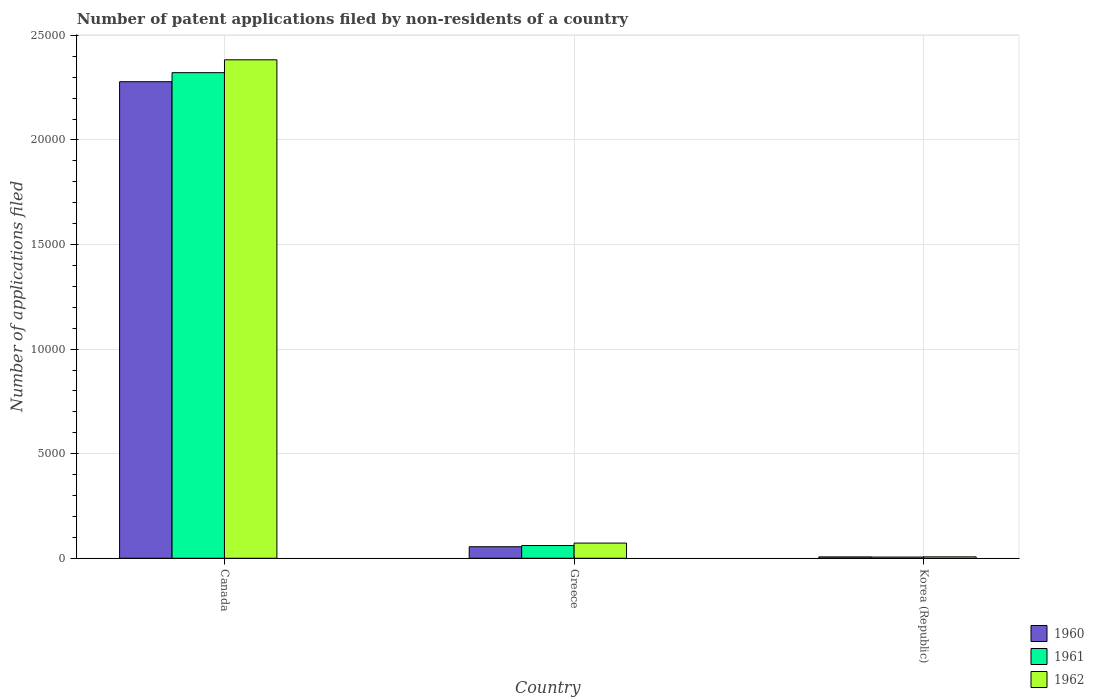How many groups of bars are there?
Your answer should be very brief. 3. Are the number of bars per tick equal to the number of legend labels?
Provide a succinct answer. Yes. Are the number of bars on each tick of the X-axis equal?
Give a very brief answer. Yes. How many bars are there on the 3rd tick from the right?
Provide a short and direct response. 3. What is the label of the 1st group of bars from the left?
Ensure brevity in your answer.  Canada. In how many cases, is the number of bars for a given country not equal to the number of legend labels?
Ensure brevity in your answer.  0. What is the number of applications filed in 1961 in Greece?
Provide a succinct answer. 609. Across all countries, what is the maximum number of applications filed in 1961?
Your answer should be compact. 2.32e+04. In which country was the number of applications filed in 1962 maximum?
Offer a terse response. Canada. In which country was the number of applications filed in 1962 minimum?
Provide a short and direct response. Korea (Republic). What is the total number of applications filed in 1961 in the graph?
Offer a very short reply. 2.39e+04. What is the difference between the number of applications filed in 1961 in Canada and that in Greece?
Ensure brevity in your answer.  2.26e+04. What is the difference between the number of applications filed in 1961 in Korea (Republic) and the number of applications filed in 1960 in Greece?
Ensure brevity in your answer.  -493. What is the average number of applications filed in 1962 per country?
Your answer should be compact. 8209.33. What is the difference between the number of applications filed of/in 1962 and number of applications filed of/in 1960 in Greece?
Provide a succinct answer. 175. In how many countries, is the number of applications filed in 1961 greater than 8000?
Provide a succinct answer. 1. Is the difference between the number of applications filed in 1962 in Canada and Greece greater than the difference between the number of applications filed in 1960 in Canada and Greece?
Your answer should be compact. Yes. What is the difference between the highest and the second highest number of applications filed in 1962?
Provide a succinct answer. 2.38e+04. What is the difference between the highest and the lowest number of applications filed in 1962?
Your answer should be very brief. 2.38e+04. Is the sum of the number of applications filed in 1961 in Greece and Korea (Republic) greater than the maximum number of applications filed in 1960 across all countries?
Your answer should be very brief. No. What does the 2nd bar from the left in Canada represents?
Make the answer very short. 1961. What does the 2nd bar from the right in Canada represents?
Keep it short and to the point. 1961. How many countries are there in the graph?
Offer a terse response. 3. Where does the legend appear in the graph?
Provide a succinct answer. Bottom right. How many legend labels are there?
Your response must be concise. 3. What is the title of the graph?
Keep it short and to the point. Number of patent applications filed by non-residents of a country. What is the label or title of the X-axis?
Your response must be concise. Country. What is the label or title of the Y-axis?
Offer a very short reply. Number of applications filed. What is the Number of applications filed in 1960 in Canada?
Your answer should be compact. 2.28e+04. What is the Number of applications filed of 1961 in Canada?
Provide a succinct answer. 2.32e+04. What is the Number of applications filed in 1962 in Canada?
Give a very brief answer. 2.38e+04. What is the Number of applications filed of 1960 in Greece?
Your response must be concise. 551. What is the Number of applications filed in 1961 in Greece?
Your answer should be very brief. 609. What is the Number of applications filed of 1962 in Greece?
Ensure brevity in your answer.  726. What is the Number of applications filed of 1961 in Korea (Republic)?
Give a very brief answer. 58. Across all countries, what is the maximum Number of applications filed in 1960?
Provide a succinct answer. 2.28e+04. Across all countries, what is the maximum Number of applications filed in 1961?
Your answer should be compact. 2.32e+04. Across all countries, what is the maximum Number of applications filed in 1962?
Your answer should be very brief. 2.38e+04. Across all countries, what is the minimum Number of applications filed in 1960?
Your answer should be compact. 66. What is the total Number of applications filed of 1960 in the graph?
Provide a succinct answer. 2.34e+04. What is the total Number of applications filed of 1961 in the graph?
Make the answer very short. 2.39e+04. What is the total Number of applications filed of 1962 in the graph?
Make the answer very short. 2.46e+04. What is the difference between the Number of applications filed in 1960 in Canada and that in Greece?
Offer a very short reply. 2.22e+04. What is the difference between the Number of applications filed of 1961 in Canada and that in Greece?
Offer a very short reply. 2.26e+04. What is the difference between the Number of applications filed of 1962 in Canada and that in Greece?
Offer a terse response. 2.31e+04. What is the difference between the Number of applications filed of 1960 in Canada and that in Korea (Republic)?
Ensure brevity in your answer.  2.27e+04. What is the difference between the Number of applications filed in 1961 in Canada and that in Korea (Republic)?
Offer a terse response. 2.32e+04. What is the difference between the Number of applications filed in 1962 in Canada and that in Korea (Republic)?
Your response must be concise. 2.38e+04. What is the difference between the Number of applications filed of 1960 in Greece and that in Korea (Republic)?
Keep it short and to the point. 485. What is the difference between the Number of applications filed of 1961 in Greece and that in Korea (Republic)?
Offer a very short reply. 551. What is the difference between the Number of applications filed in 1962 in Greece and that in Korea (Republic)?
Provide a short and direct response. 658. What is the difference between the Number of applications filed of 1960 in Canada and the Number of applications filed of 1961 in Greece?
Ensure brevity in your answer.  2.22e+04. What is the difference between the Number of applications filed of 1960 in Canada and the Number of applications filed of 1962 in Greece?
Provide a succinct answer. 2.21e+04. What is the difference between the Number of applications filed of 1961 in Canada and the Number of applications filed of 1962 in Greece?
Ensure brevity in your answer.  2.25e+04. What is the difference between the Number of applications filed in 1960 in Canada and the Number of applications filed in 1961 in Korea (Republic)?
Make the answer very short. 2.27e+04. What is the difference between the Number of applications filed in 1960 in Canada and the Number of applications filed in 1962 in Korea (Republic)?
Offer a terse response. 2.27e+04. What is the difference between the Number of applications filed in 1961 in Canada and the Number of applications filed in 1962 in Korea (Republic)?
Make the answer very short. 2.32e+04. What is the difference between the Number of applications filed in 1960 in Greece and the Number of applications filed in 1961 in Korea (Republic)?
Provide a succinct answer. 493. What is the difference between the Number of applications filed in 1960 in Greece and the Number of applications filed in 1962 in Korea (Republic)?
Your response must be concise. 483. What is the difference between the Number of applications filed of 1961 in Greece and the Number of applications filed of 1962 in Korea (Republic)?
Keep it short and to the point. 541. What is the average Number of applications filed in 1960 per country?
Your answer should be compact. 7801. What is the average Number of applications filed in 1961 per country?
Your response must be concise. 7962. What is the average Number of applications filed of 1962 per country?
Provide a short and direct response. 8209.33. What is the difference between the Number of applications filed of 1960 and Number of applications filed of 1961 in Canada?
Your answer should be compact. -433. What is the difference between the Number of applications filed in 1960 and Number of applications filed in 1962 in Canada?
Keep it short and to the point. -1048. What is the difference between the Number of applications filed of 1961 and Number of applications filed of 1962 in Canada?
Offer a terse response. -615. What is the difference between the Number of applications filed of 1960 and Number of applications filed of 1961 in Greece?
Give a very brief answer. -58. What is the difference between the Number of applications filed in 1960 and Number of applications filed in 1962 in Greece?
Offer a very short reply. -175. What is the difference between the Number of applications filed in 1961 and Number of applications filed in 1962 in Greece?
Your answer should be very brief. -117. What is the difference between the Number of applications filed of 1960 and Number of applications filed of 1961 in Korea (Republic)?
Your response must be concise. 8. What is the difference between the Number of applications filed in 1960 and Number of applications filed in 1962 in Korea (Republic)?
Your answer should be compact. -2. What is the ratio of the Number of applications filed in 1960 in Canada to that in Greece?
Offer a terse response. 41.35. What is the ratio of the Number of applications filed in 1961 in Canada to that in Greece?
Keep it short and to the point. 38.13. What is the ratio of the Number of applications filed of 1962 in Canada to that in Greece?
Provide a short and direct response. 32.83. What is the ratio of the Number of applications filed in 1960 in Canada to that in Korea (Republic)?
Make the answer very short. 345.24. What is the ratio of the Number of applications filed in 1961 in Canada to that in Korea (Republic)?
Make the answer very short. 400.33. What is the ratio of the Number of applications filed in 1962 in Canada to that in Korea (Republic)?
Make the answer very short. 350.5. What is the ratio of the Number of applications filed of 1960 in Greece to that in Korea (Republic)?
Give a very brief answer. 8.35. What is the ratio of the Number of applications filed in 1961 in Greece to that in Korea (Republic)?
Make the answer very short. 10.5. What is the ratio of the Number of applications filed in 1962 in Greece to that in Korea (Republic)?
Ensure brevity in your answer.  10.68. What is the difference between the highest and the second highest Number of applications filed in 1960?
Provide a succinct answer. 2.22e+04. What is the difference between the highest and the second highest Number of applications filed of 1961?
Give a very brief answer. 2.26e+04. What is the difference between the highest and the second highest Number of applications filed in 1962?
Provide a succinct answer. 2.31e+04. What is the difference between the highest and the lowest Number of applications filed in 1960?
Your answer should be very brief. 2.27e+04. What is the difference between the highest and the lowest Number of applications filed of 1961?
Provide a succinct answer. 2.32e+04. What is the difference between the highest and the lowest Number of applications filed of 1962?
Provide a succinct answer. 2.38e+04. 